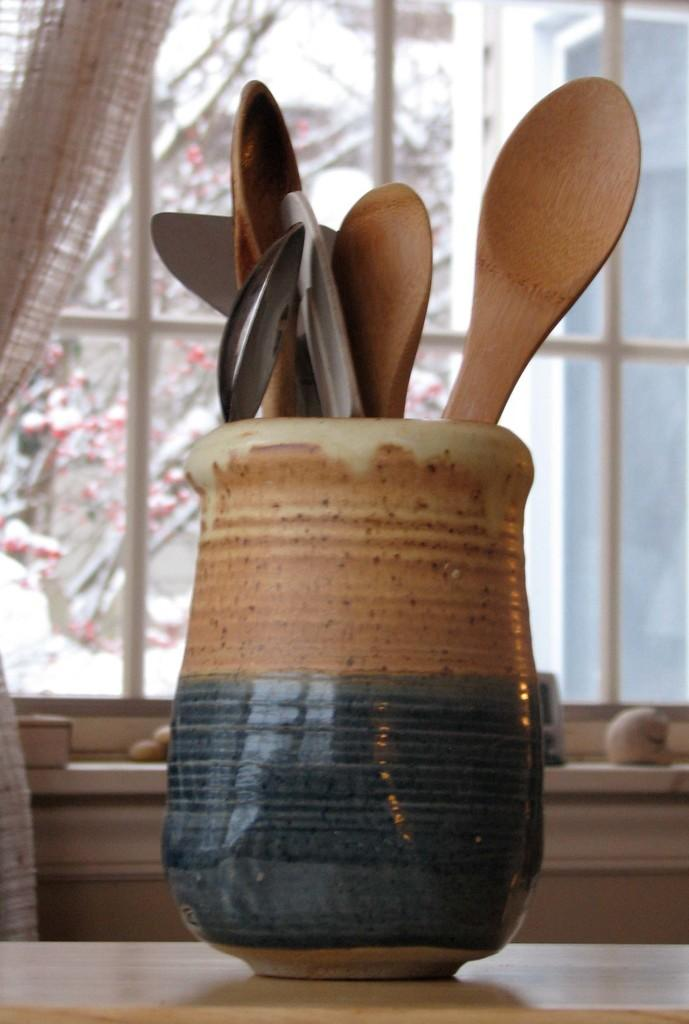What can be seen in the image that provides a view of the outdoors? There is a window in the image that provides a view of the outdoors. What piece of furniture is present in the image? There is a table in the image. What is on the table? There is a flask on the table. What is inside the flask? There are spoons in the flask. What can be seen outside the window? There is a tree visible outside the window. How many beads are present on the table in the image? There are no beads mentioned or visible in the image. What error can be corrected in the image? There is no error present in the image; it accurately depicts the scene described in the facts. 